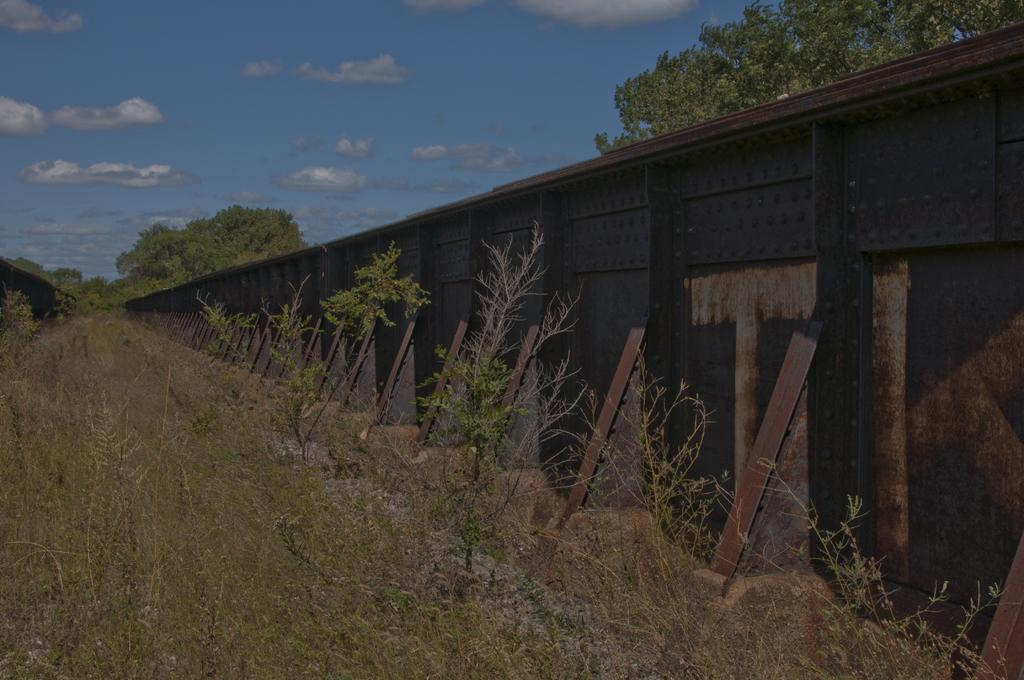What structure is the main subject of the image? There is a bridge in the image. What can be seen in the background of the image? There are plants and trees in the background of the image. How would you describe the sky in the image? The sky is cloudy in the image. Where is the dad standing with the jewel in the image? There is no dad or jewel present in the image. 